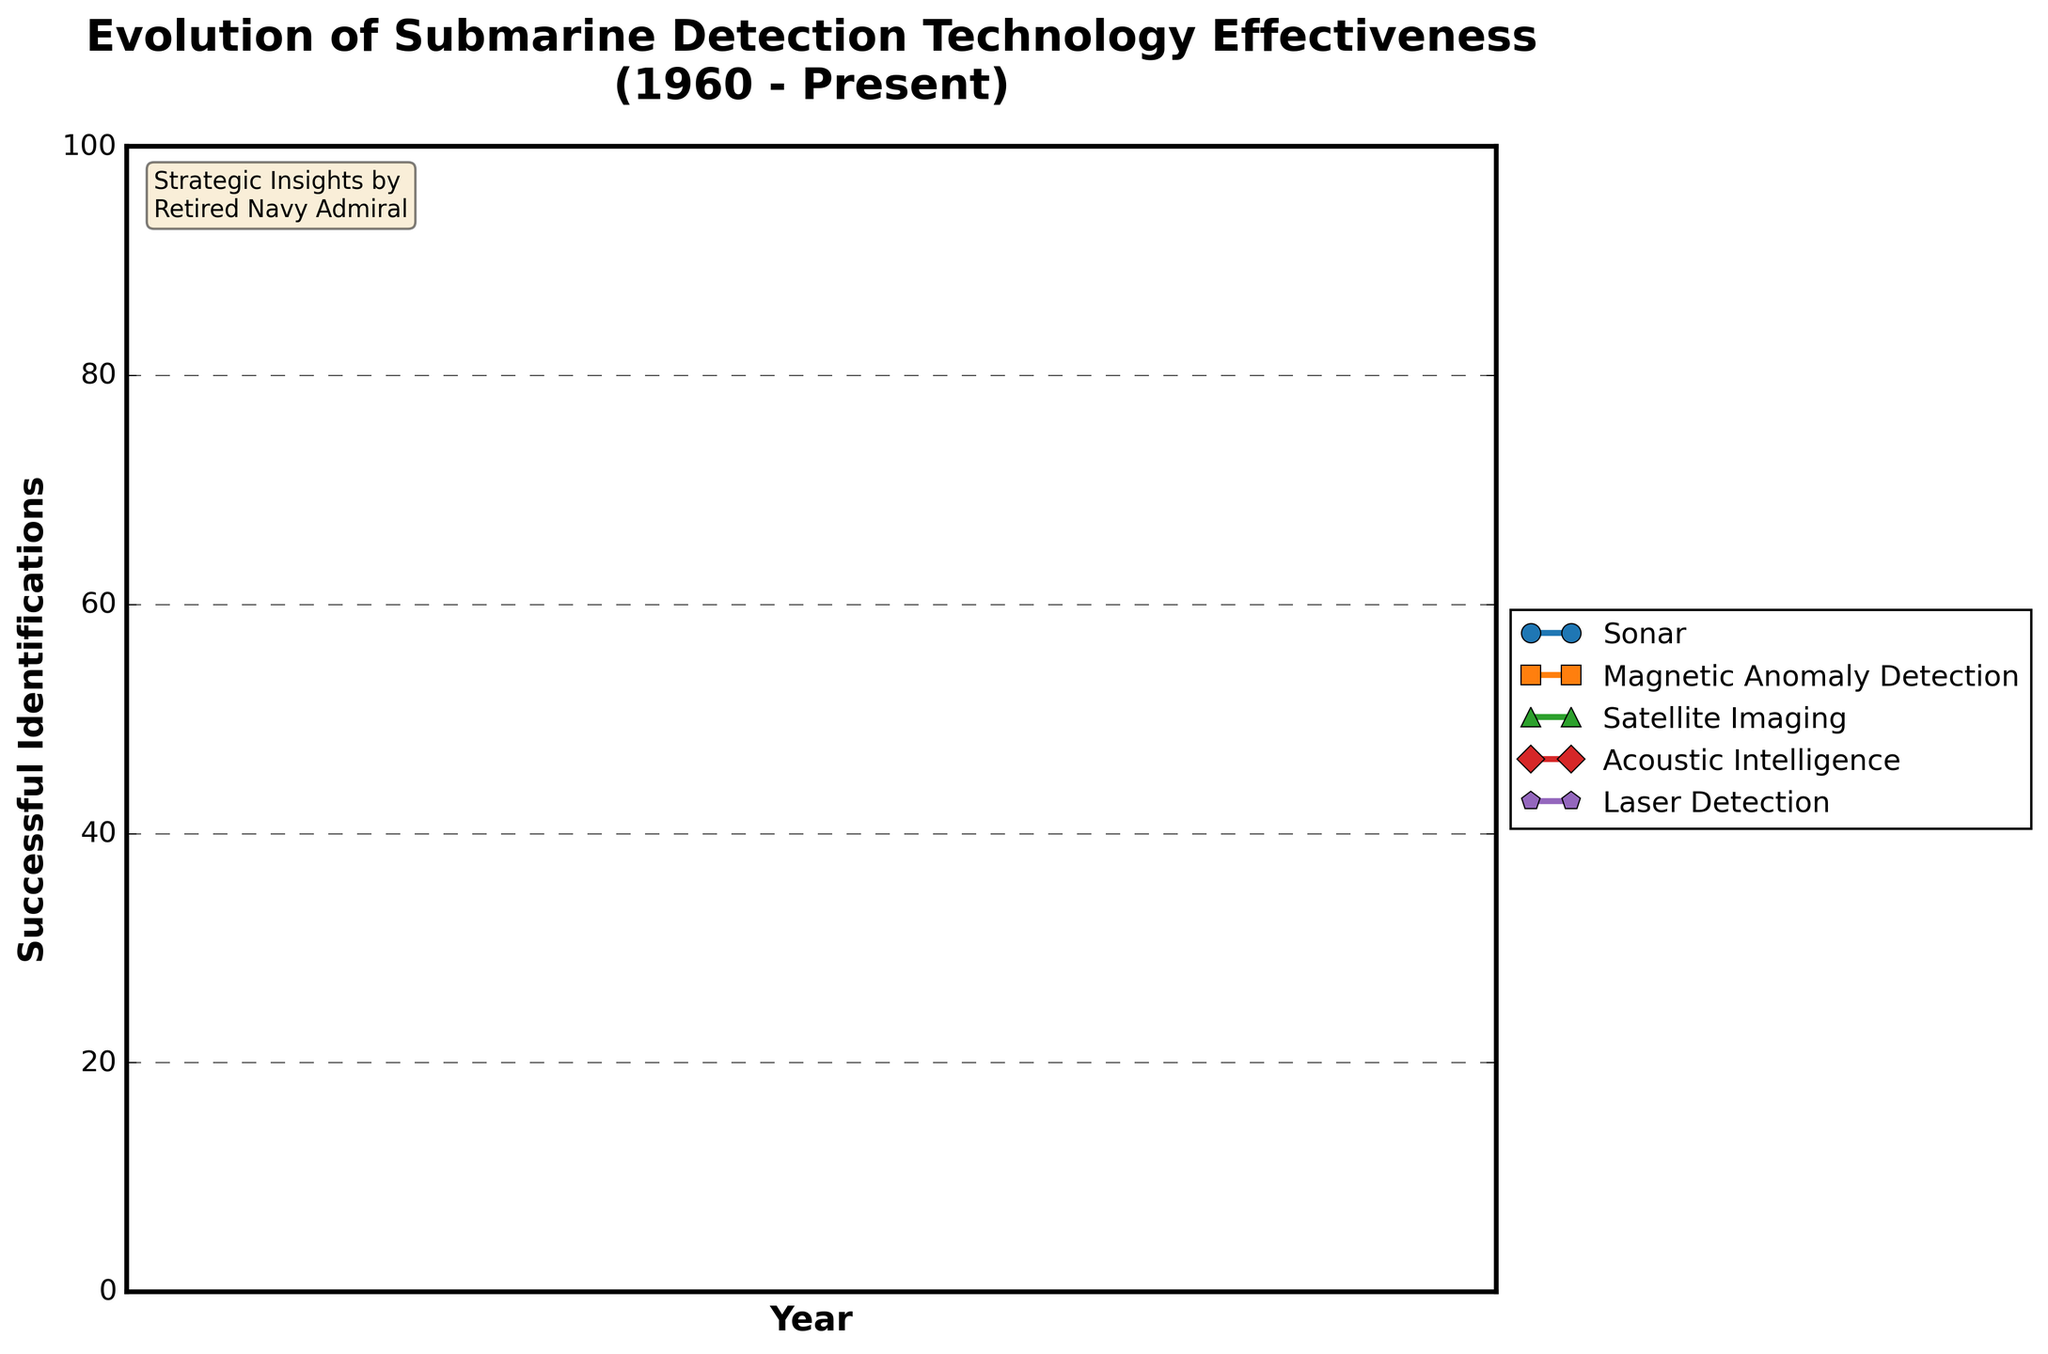How has sonar technology's effectiveness changed from 1960 to the present? Sonar effectiveness has increased steadily from 20 successful identifications in 1960 to 95 in the present. Observe the upward sloping line for Sonar starting at 20 in 1960 and ending at 95 in the present year.
Answer: It has increased from 20 to 95 Which technology had the most significant improvement between 1960 and 2020? Calculate the difference in successful identifications for each technology between 1960 and 2020. Sonar increased by 70 (90 - 20), MAD by 70 (80 - 10), Satellite Imaging by 85 (85 - 0), Acoustic Intelligence by 80 (85 - 5), and Laser Detection by 70 (70 - 0). Satellite Imaging had the highest improvement.
Answer: Satellite Imaging In which decade did Acoustic Intelligence surpass Magnetic Anomaly Detection (MAD) in effectiveness? Compare the values of Acoustic Intelligence and MAD for each decade. Acoustic Intelligence surpassed MAD in the 1980s (30 > 25).
Answer: 1980s What is the average effectiveness of Laser Detection from 1960 to the present? Sum the values for Laser Detection across all years (0 + 0 + 5 + 15 + 30 + 50 + 70 + 80 = 250) and divide by the number of data points (8). The result is 250/8.
Answer: 31.25 How does the effectiveness of Sonar in 2000 compare to 1970? Compare the values of Sonar in both years. In 2000 Sonar had 75 successful identifications and in 1970 it was 35, showing an increase of 40.
Answer: It increased by 40 What are the top three technologies in terms of effectiveness in the present year? Compare the values for all technologies in the present year. The highest values are Sonar (95), MAD (85), and Acoustic Intelligence (90). Therefore, the top three are Sonar, Acoustic Intelligence, and MAD.
Answer: Sonar, Acoustic Intelligence, MAD Which technology showed the first significant increase between 1960 and 1970? Observe the relative increases for each technology from 1960 to 1970. Sonar increased by 15 (20 to 35), MAD by 15 (10 to 25), Satellite Imaging by 5 (0 to 5), and Acoustic Intelligence by 10 (5 to 15). Sonar and MAD had the first significant increases (15).
Answer: Sonar, MAD How many technologies reached effectiveness levels above 50 by the year 2000? Count the technologies with values greater than 50 in the year 2000. Sonar (75), MAD (65), and Acoustic Intelligence (60) are the technologies above 50. There are 3 such technologies.
Answer: 3 What trends can be observed in the effectiveness of Satellite Imaging over the period from 1960 to the present? Satellite Imaging starts at 0 and rises consistently, reaching 90 by the present year. The trend is linear and steady, showing continuous improvement without significant fluctuations.
Answer: Steady increase Between which two periods did Laser Detection see its most considerable leap in effectiveness? Look for the greatest difference between consecutive data points for Laser Detection. The most considerable leap is between 2000 (30) and 2010 (50), an increase of 20.
Answer: 2000 to 2010 